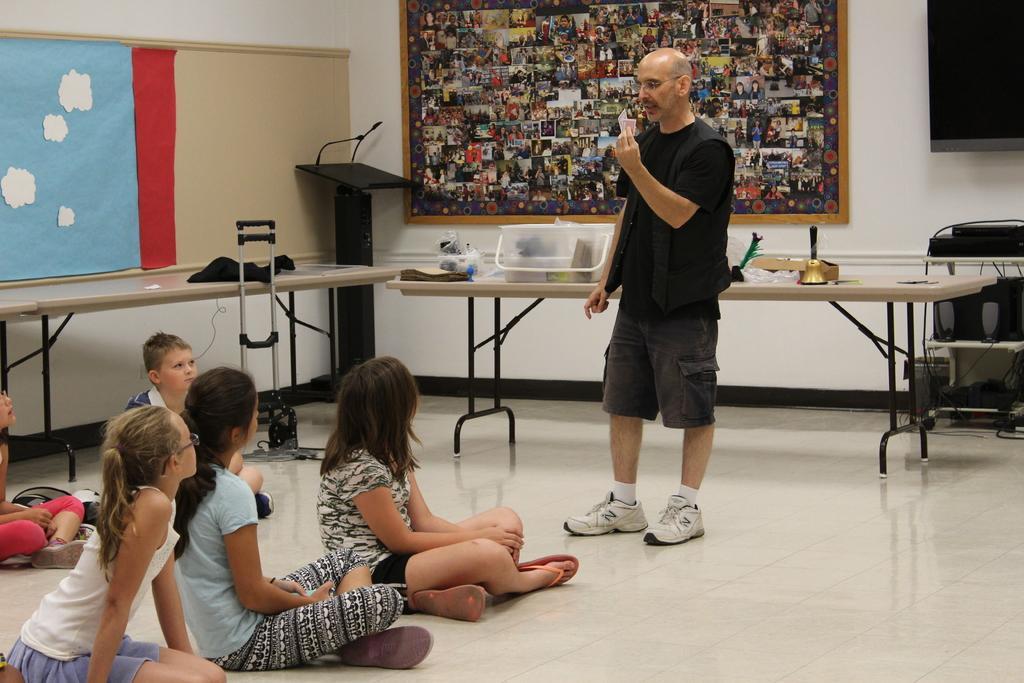Please provide a concise description of this image. In this image I can see a person standing on the floor. On the left side I can see some kids sitting on the floor. In the background, I can see the objects on the table. I can also see some photographs on the board. 